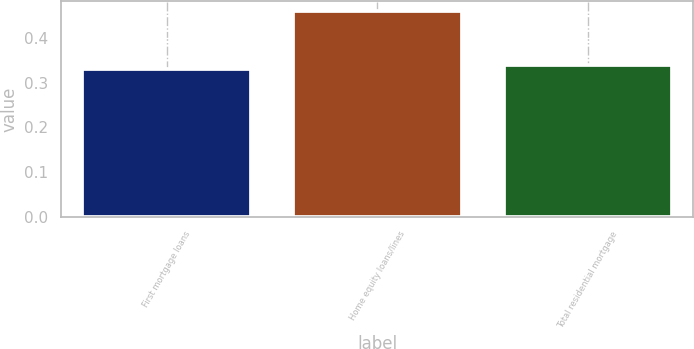<chart> <loc_0><loc_0><loc_500><loc_500><bar_chart><fcel>First mortgage loans<fcel>Home equity loans/lines<fcel>Total residential mortgage<nl><fcel>0.33<fcel>0.46<fcel>0.34<nl></chart> 